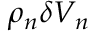Convert formula to latex. <formula><loc_0><loc_0><loc_500><loc_500>\rho _ { n } \delta V _ { n }</formula> 